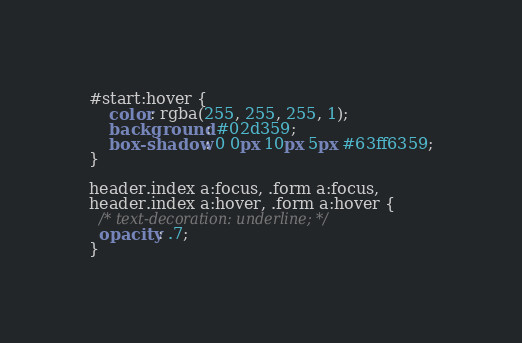Convert code to text. <code><loc_0><loc_0><loc_500><loc_500><_CSS_>#start:hover {
    color: rgba(255, 255, 255, 1);
    background: #02d359;
    box-shadow: 0 0px 10px 5px #63ff6359;
}

header.index a:focus, .form a:focus,
header.index a:hover, .form a:hover {
  /* text-decoration: underline; */
  opacity: .7;
}</code> 